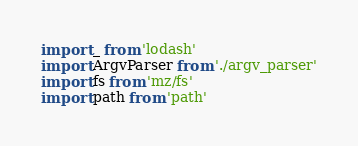<code> <loc_0><loc_0><loc_500><loc_500><_JavaScript_>import _ from 'lodash'
import ArgvParser from './argv_parser'
import fs from 'mz/fs'
import path from 'path'</code> 